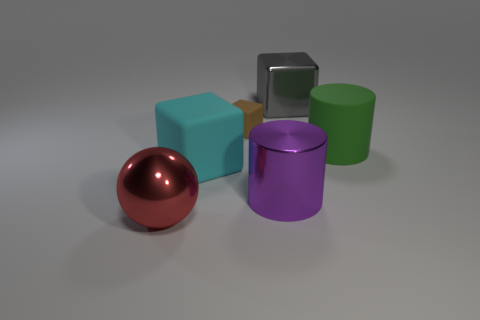Is there anything else that is the same size as the brown object?
Provide a succinct answer. No. There is a large block on the left side of the metal cube; what color is it?
Your response must be concise. Cyan. Is the number of cyan objects in front of the green cylinder greater than the number of purple cylinders to the left of the metallic sphere?
Make the answer very short. Yes. How big is the matte block that is behind the large cube in front of the large matte object that is to the right of the metal block?
Offer a very short reply. Small. What number of tiny cyan matte cubes are there?
Keep it short and to the point. 0. There is a cylinder that is to the right of the cylinder that is on the left side of the big cylinder that is right of the metallic cube; what is it made of?
Make the answer very short. Rubber. Is there a green cylinder that has the same material as the big cyan block?
Your answer should be very brief. Yes. Do the big cyan block and the tiny thing have the same material?
Keep it short and to the point. Yes. What number of spheres are large red things or big green matte things?
Offer a very short reply. 1. What color is the cube that is the same material as the large ball?
Provide a short and direct response. Gray. 